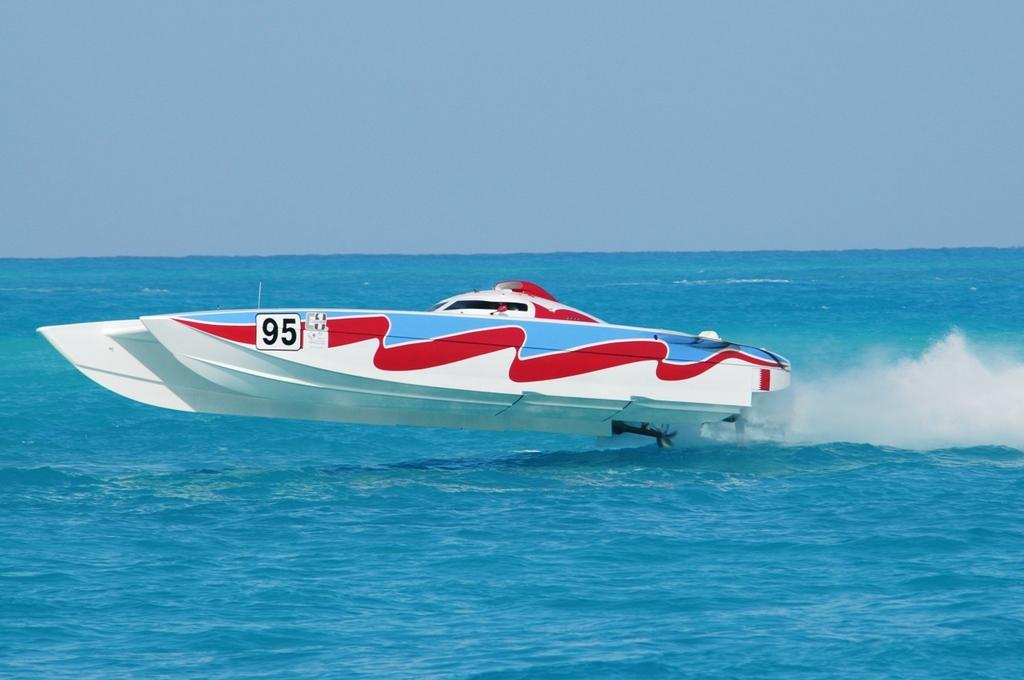What is the main subject of the image? The main subject of the image is a boat. What is the boat doing in the image? The boat is sailing on water. What can be seen in the water around the boat? There are tides in the water. What is visible at the top of the image? The sky is visible at the top of the image. How does the girl play with the account in the image? There is no girl or account present in the image; it features a boat sailing on water with visible tides and a sky. 